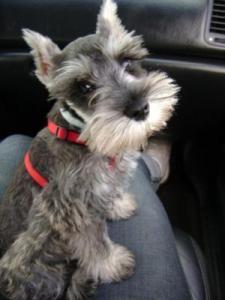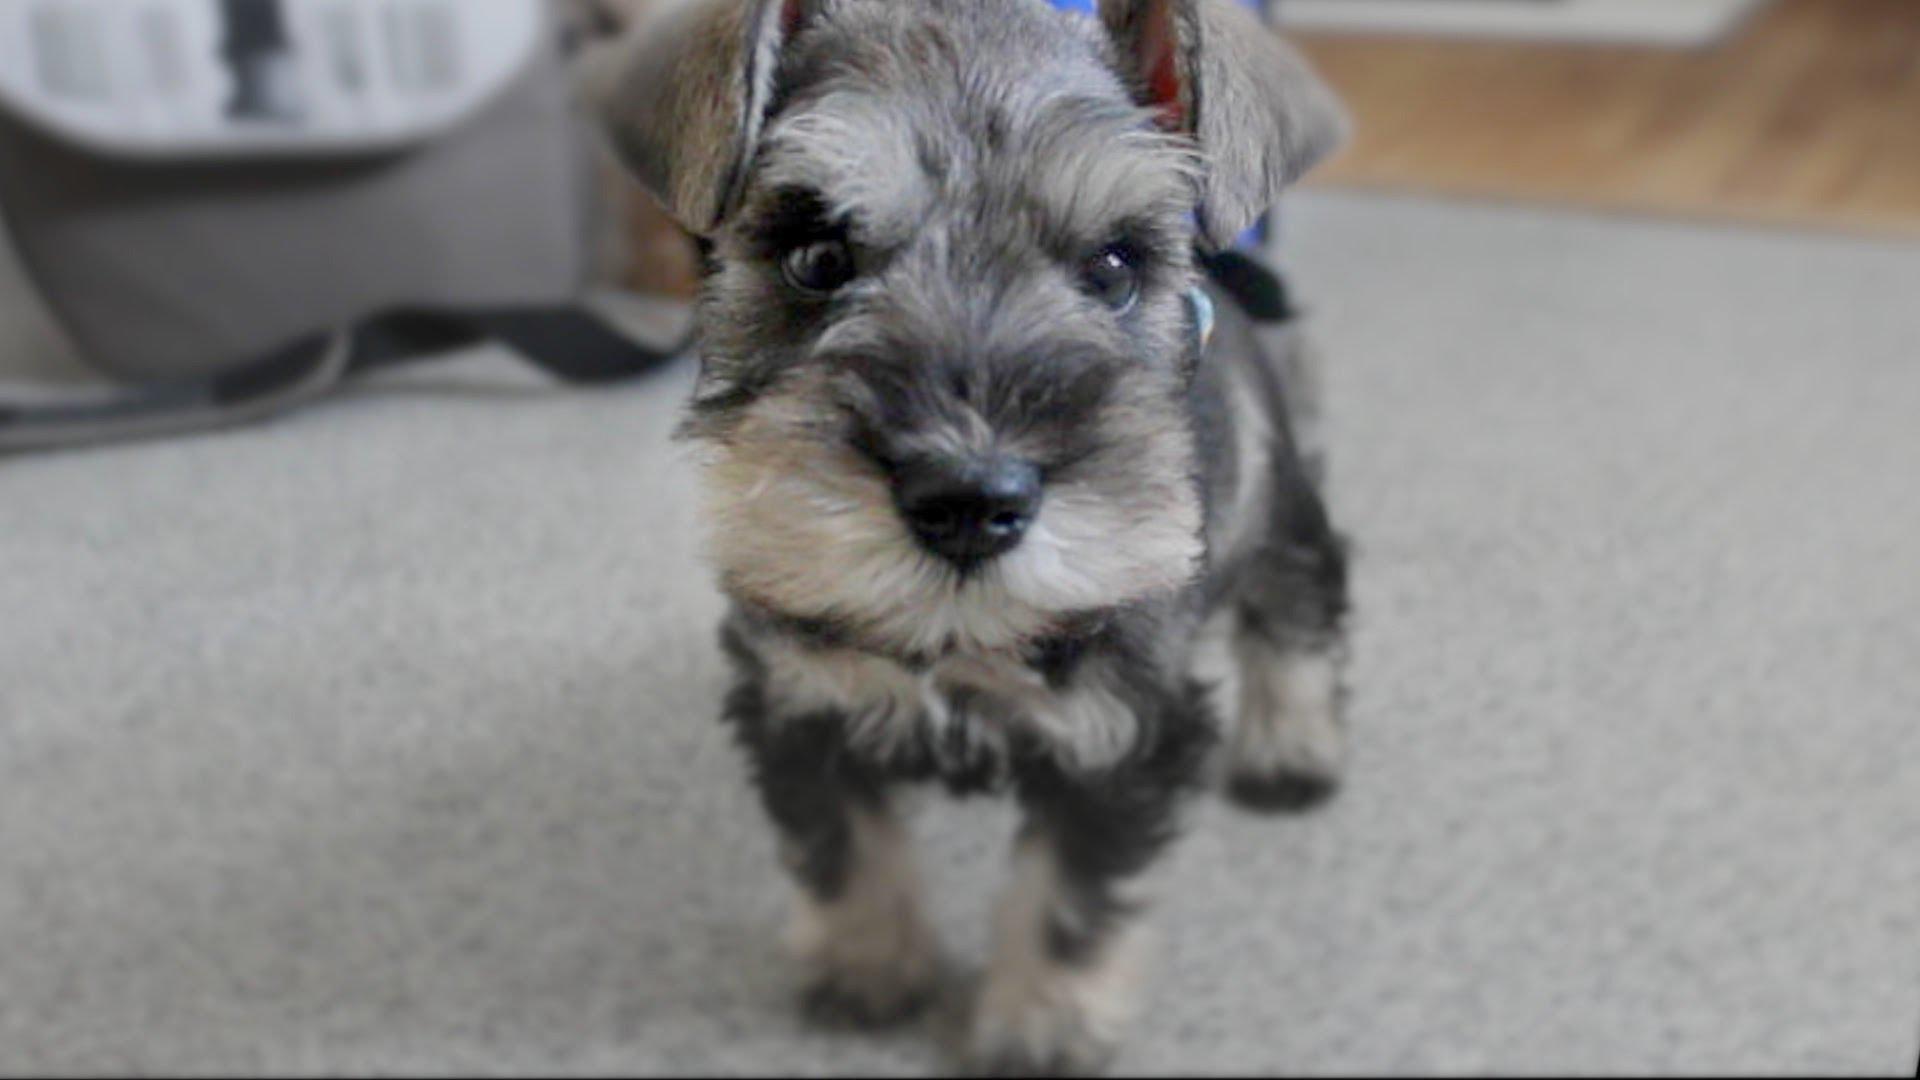The first image is the image on the left, the second image is the image on the right. Given the left and right images, does the statement "The dogs have collars on them." hold true? Answer yes or no. Yes. 